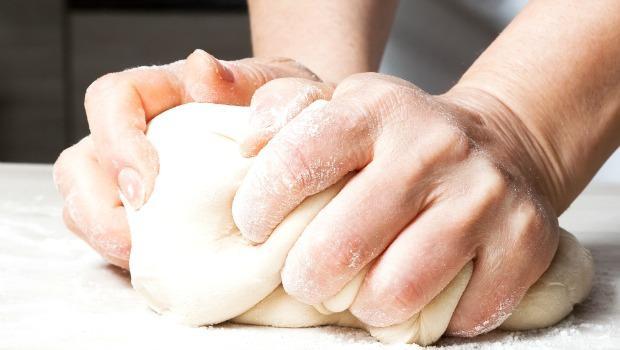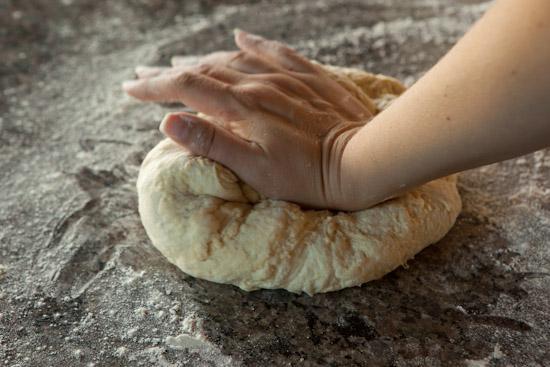The first image is the image on the left, the second image is the image on the right. Given the left and right images, does the statement "The heel of a hand is punching down a ball of dough on a floured surface in the right image." hold true? Answer yes or no. Yes. The first image is the image on the left, the second image is the image on the right. For the images displayed, is the sentence "There are three hands visible." factually correct? Answer yes or no. Yes. 